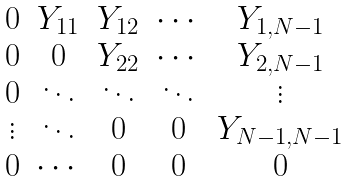<formula> <loc_0><loc_0><loc_500><loc_500>\begin{matrix} 0 & Y _ { 1 1 } & Y _ { 1 2 } & \cdots & Y _ { 1 , N - 1 } \\ 0 & 0 & Y _ { 2 2 } & \cdots & Y _ { 2 , N - 1 } \\ 0 & \ddots & \ddots & \ddots & \vdots \\ \vdots & \ddots & 0 & 0 & Y _ { N - 1 , N - 1 } \\ 0 & \cdots & 0 & 0 & 0 \end{matrix}</formula> 